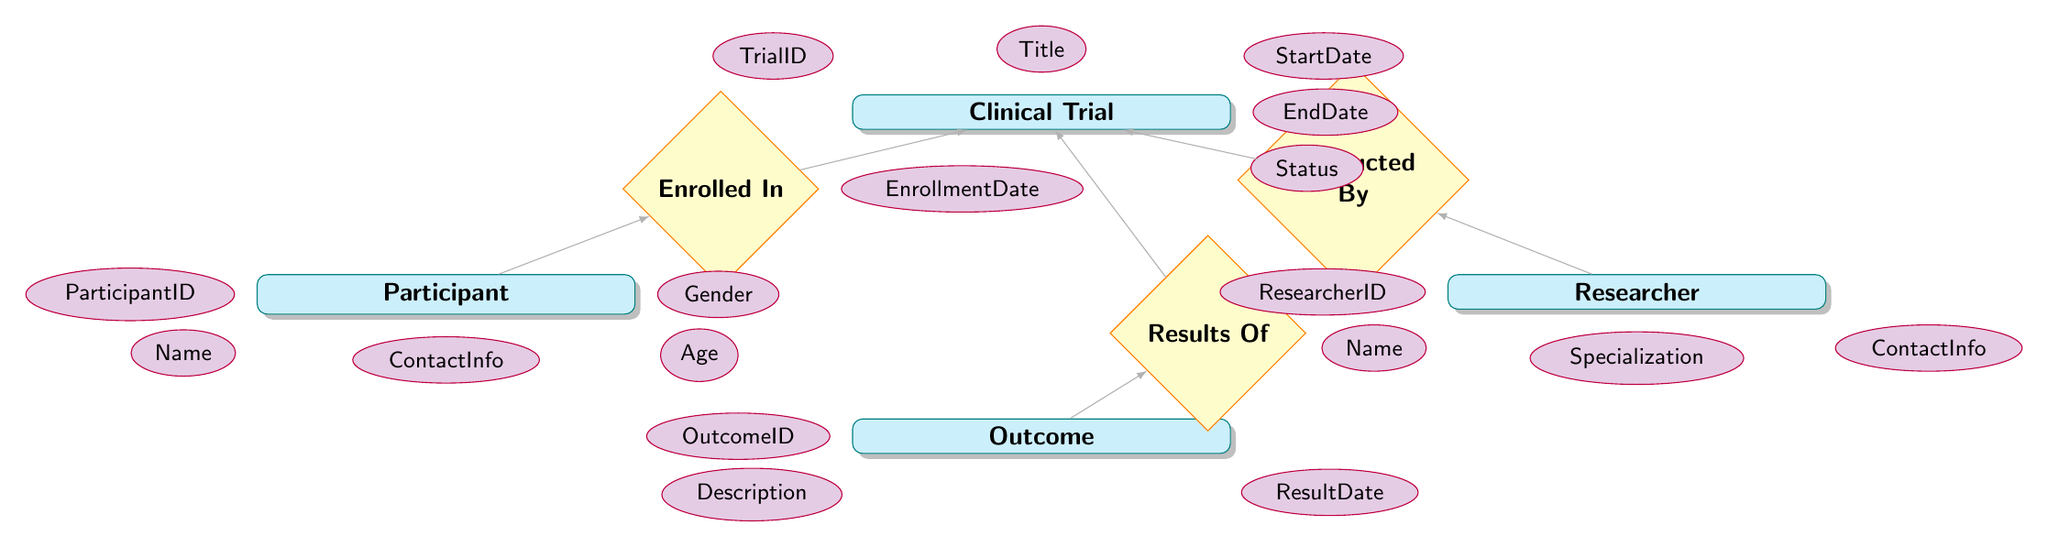What is the primary entity that represents a study in the diagram? The primary entity in the diagram is "ClinicalTrial" as it serves as the main focus of the research study process and is at the top of the diagram.
Answer: ClinicalTrial How many attributes does the "Participant" entity have? The "Participant" entity has five attributes: ParticipantID, Name, ContactInfo, Age, and Gender. By counting them from the diagram, we can affirm this.
Answer: 5 What relationship connects "Participant" and "ClinicalTrial"? The relationship that connects "Participant" to "ClinicalTrial" is labeled "Enrolled In," which indicates that participants are involved in specific clinical trials.
Answer: Enrolled In Which attributes are linked to the "Researcher" entity? The attributes linked to the "Researcher" entity include ResearcherID, Name, Specialization, and ContactInfo. By identifying these from the diagram, we can clearly enumerate them.
Answer: ResearcherID, Name, Specialization, ContactInfo What does the "Results Of" relationship signify in the context of the diagram? The "Results Of" relationship indicates that an "Outcome" is derived from a specific "ClinicalTrial." It shows the end results of each trial, connecting outcomes to trials.
Answer: Outcome Which entity's attributes contain "TrialID" and "Status"? Both "TrialID" and "Status" are attributes found in the "ClinicalTrial" entity, which contains various identifiers and metrics for managing the trials within the context of the study.
Answer: ClinicalTrial How are the "Outcome" and "ClinicalTrial" entities related? The "Outcome" and "ClinicalTrial" entities are related through the "Results Of" relationship, which provides a direct link showing how outcomes are produced from clinical trials.
Answer: Results Of How many relationships are depicted in the diagram? There are three relationships depicted in the diagram: "Enrolled In," "Conducted By," and "Results Of." Counting these relationships indicates the connections between the entities.
Answer: 3 